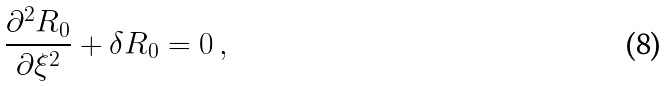Convert formula to latex. <formula><loc_0><loc_0><loc_500><loc_500>\frac { \partial ^ { 2 } R _ { 0 } } { \partial \xi ^ { 2 } } + \delta R _ { 0 } = 0 \, ,</formula> 